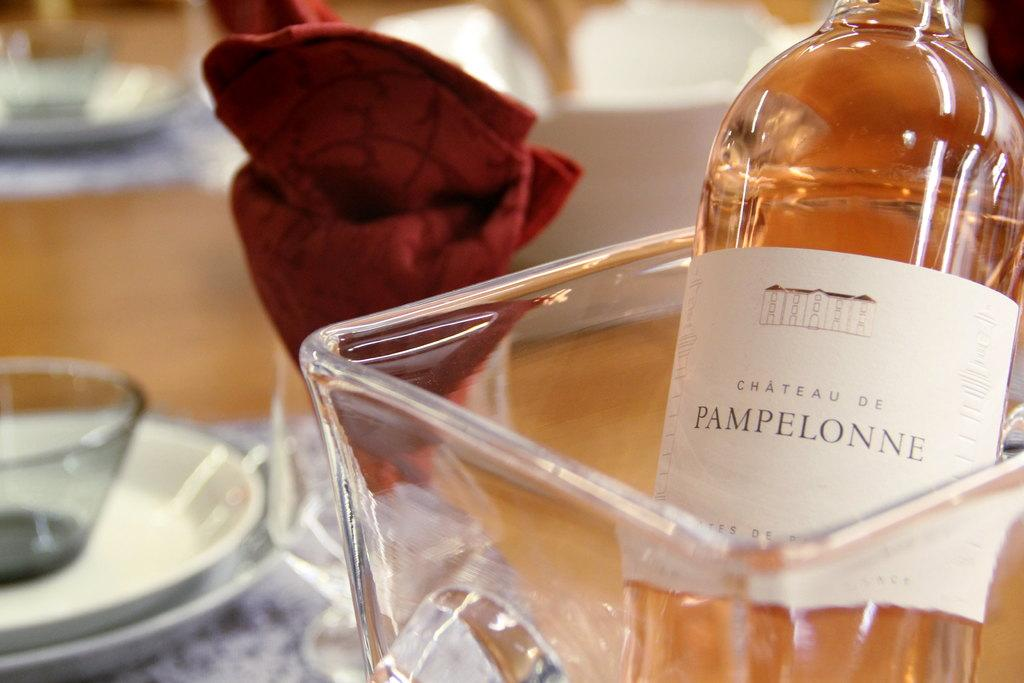Provide a one-sentence caption for the provided image. A bottle of wine from Chateau de Pampelonne is chilling in a glass jar next to a red napkin folded into a flower shape. 